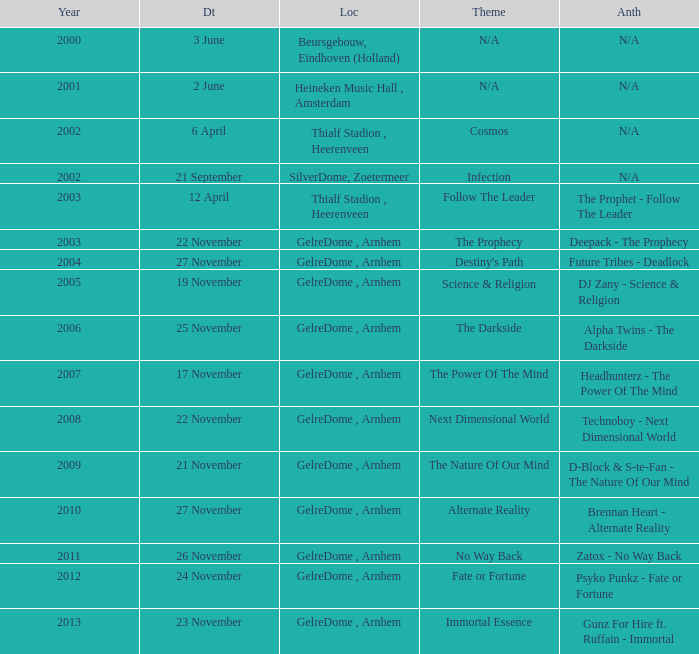What is the location in 2007? GelreDome , Arnhem. 